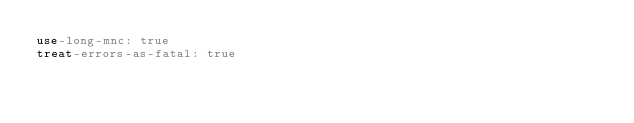Convert code to text. <code><loc_0><loc_0><loc_500><loc_500><_YAML_>use-long-mnc: true
treat-errors-as-fatal: true</code> 